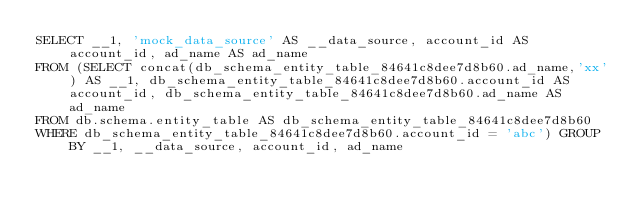Convert code to text. <code><loc_0><loc_0><loc_500><loc_500><_SQL_>SELECT __1, 'mock_data_source' AS __data_source, account_id AS account_id, ad_name AS ad_name 
FROM (SELECT concat(db_schema_entity_table_84641c8dee7d8b60.ad_name,'xx') AS __1, db_schema_entity_table_84641c8dee7d8b60.account_id AS account_id, db_schema_entity_table_84641c8dee7d8b60.ad_name AS ad_name 
FROM db.schema.entity_table AS db_schema_entity_table_84641c8dee7d8b60  
WHERE db_schema_entity_table_84641c8dee7d8b60.account_id = 'abc') GROUP BY __1, __data_source, account_id, ad_name</code> 